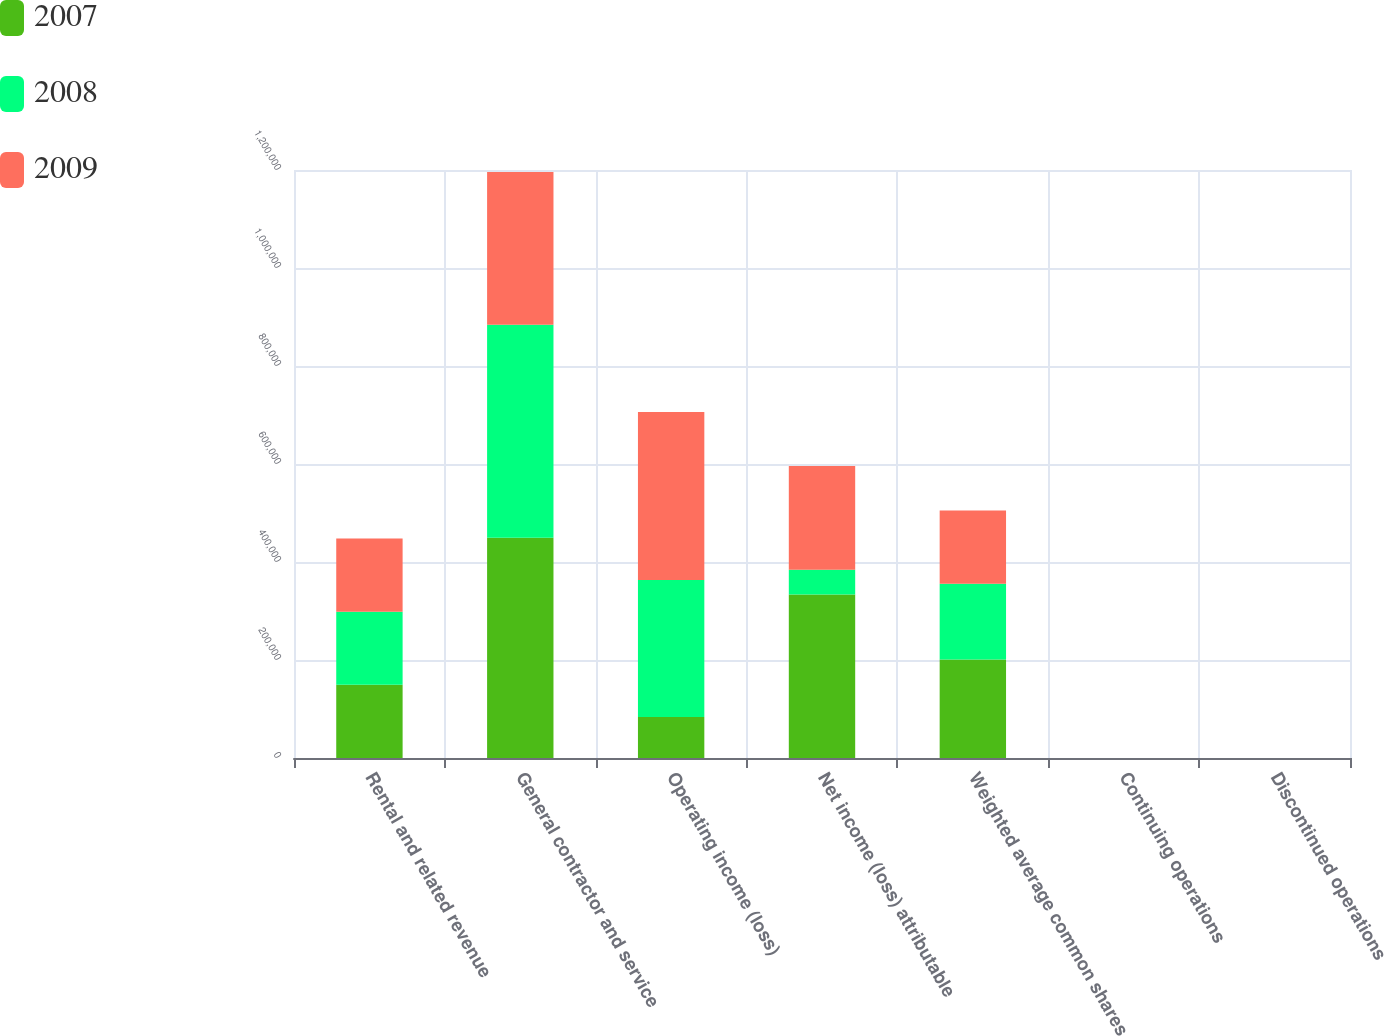<chart> <loc_0><loc_0><loc_500><loc_500><stacked_bar_chart><ecel><fcel>Rental and related revenue<fcel>General contractor and service<fcel>Operating income (loss)<fcel>Net income (loss) attributable<fcel>Weighted average common shares<fcel>Continuing operations<fcel>Discontinued operations<nl><fcel>2007<fcel>149250<fcel>449509<fcel>83763<fcel>333601<fcel>201206<fcel>1.7<fcel>0.03<nl><fcel>2008<fcel>149250<fcel>434624<fcel>279568<fcel>50408<fcel>154553<fcel>0.2<fcel>0.13<nl><fcel>2009<fcel>149250<fcel>311548<fcel>342905<fcel>211942<fcel>149250<fcel>0.6<fcel>0.91<nl></chart> 